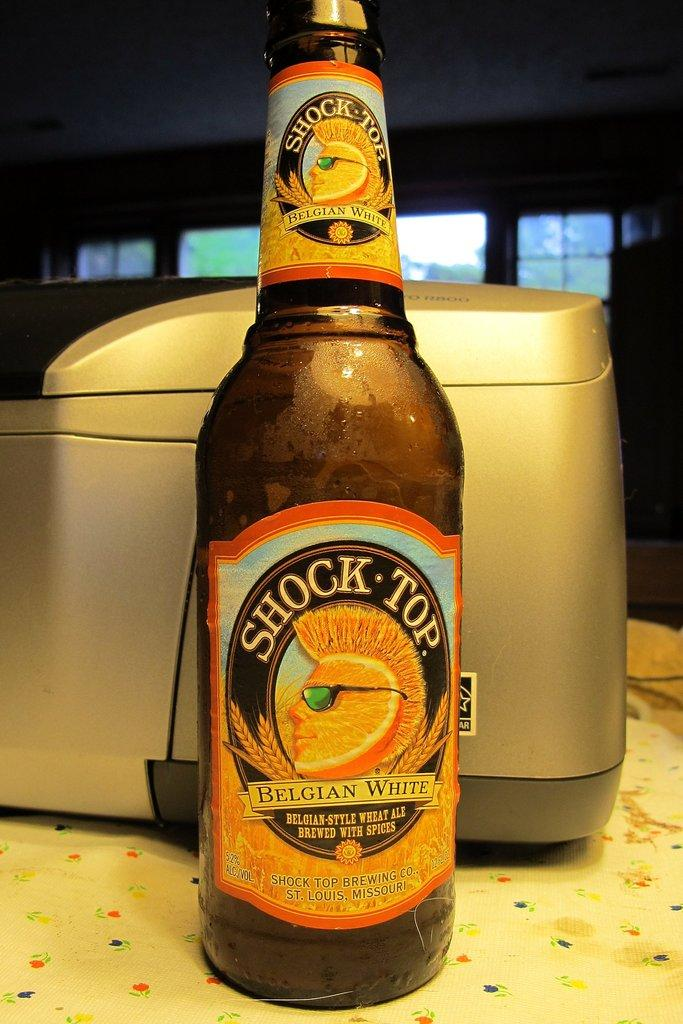<image>
Offer a succinct explanation of the picture presented. Twelve fluid ounce bottle of Shock Top Belgian white Ale. 